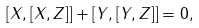Convert formula to latex. <formula><loc_0><loc_0><loc_500><loc_500>[ X , [ X , Z ] ] + [ Y , [ Y , Z ] ] = 0 ,</formula> 